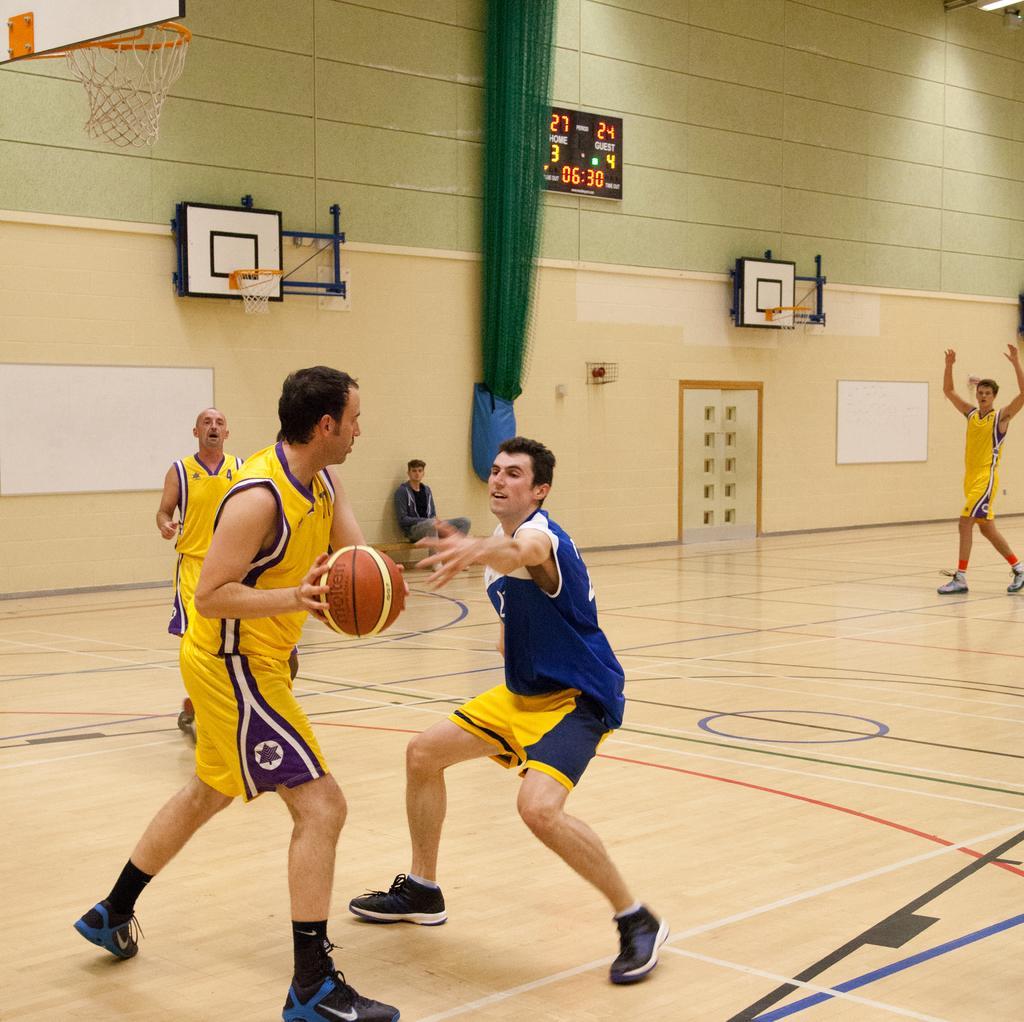Please provide a concise description of this image. In this image we can see the persons standing on the floor and there is the other person holding a ball. And at the back we can see the wall with the door and there are boards attached to the wall. And there is the board with numbers. We can see the basketball net and a green color object. 